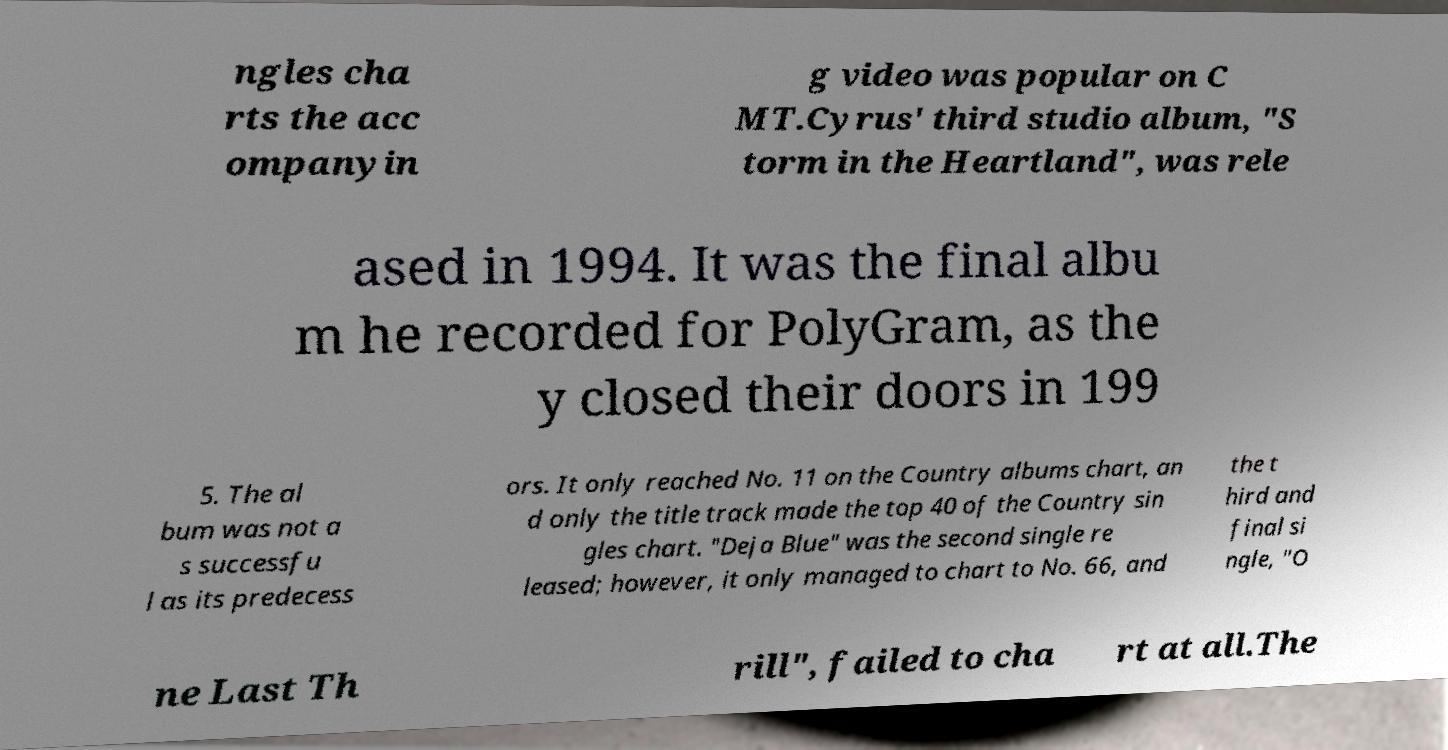There's text embedded in this image that I need extracted. Can you transcribe it verbatim? ngles cha rts the acc ompanyin g video was popular on C MT.Cyrus' third studio album, "S torm in the Heartland", was rele ased in 1994. It was the final albu m he recorded for PolyGram, as the y closed their doors in 199 5. The al bum was not a s successfu l as its predecess ors. It only reached No. 11 on the Country albums chart, an d only the title track made the top 40 of the Country sin gles chart. "Deja Blue" was the second single re leased; however, it only managed to chart to No. 66, and the t hird and final si ngle, "O ne Last Th rill", failed to cha rt at all.The 